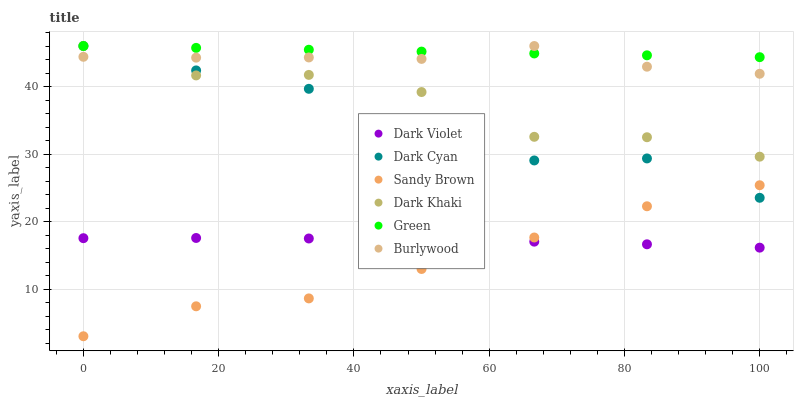Does Sandy Brown have the minimum area under the curve?
Answer yes or no. Yes. Does Green have the maximum area under the curve?
Answer yes or no. Yes. Does Dark Violet have the minimum area under the curve?
Answer yes or no. No. Does Dark Violet have the maximum area under the curve?
Answer yes or no. No. Is Green the smoothest?
Answer yes or no. Yes. Is Dark Khaki the roughest?
Answer yes or no. Yes. Is Dark Violet the smoothest?
Answer yes or no. No. Is Dark Violet the roughest?
Answer yes or no. No. Does Sandy Brown have the lowest value?
Answer yes or no. Yes. Does Dark Violet have the lowest value?
Answer yes or no. No. Does Dark Cyan have the highest value?
Answer yes or no. Yes. Does Dark Violet have the highest value?
Answer yes or no. No. Is Sandy Brown less than Dark Khaki?
Answer yes or no. Yes. Is Dark Khaki greater than Sandy Brown?
Answer yes or no. Yes. Does Burlywood intersect Dark Cyan?
Answer yes or no. Yes. Is Burlywood less than Dark Cyan?
Answer yes or no. No. Is Burlywood greater than Dark Cyan?
Answer yes or no. No. Does Sandy Brown intersect Dark Khaki?
Answer yes or no. No. 